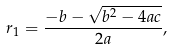<formula> <loc_0><loc_0><loc_500><loc_500>r _ { 1 } = { \frac { - b - { \sqrt { b ^ { 2 } - 4 a c } } } { 2 a } } ,</formula> 